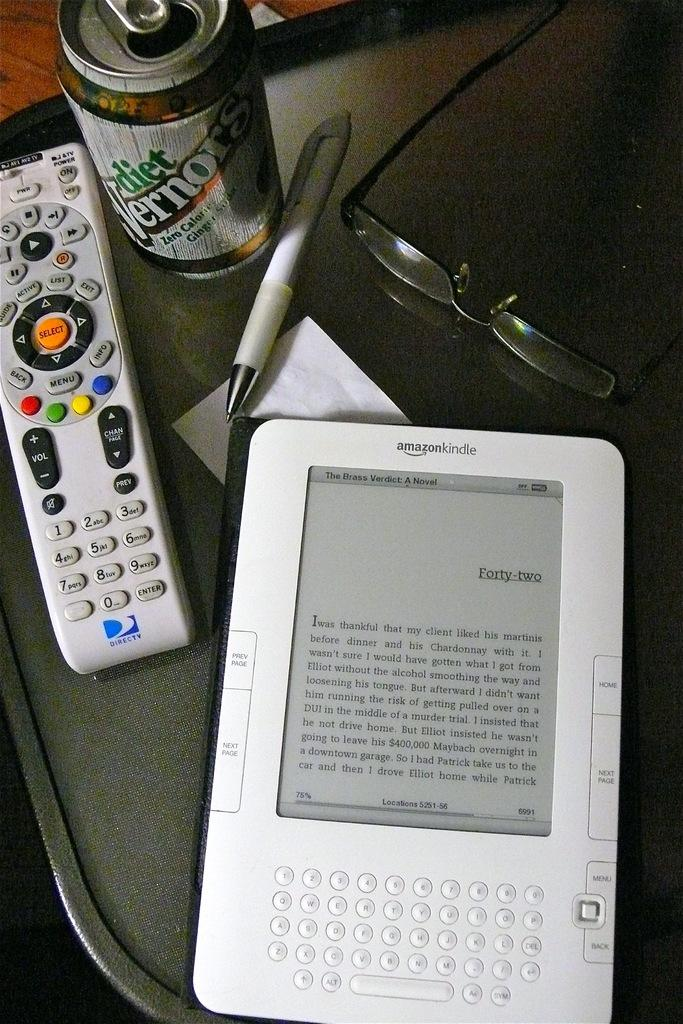<image>
Share a concise interpretation of the image provided. A television remote control sitting next to an Amazon Kindle. 